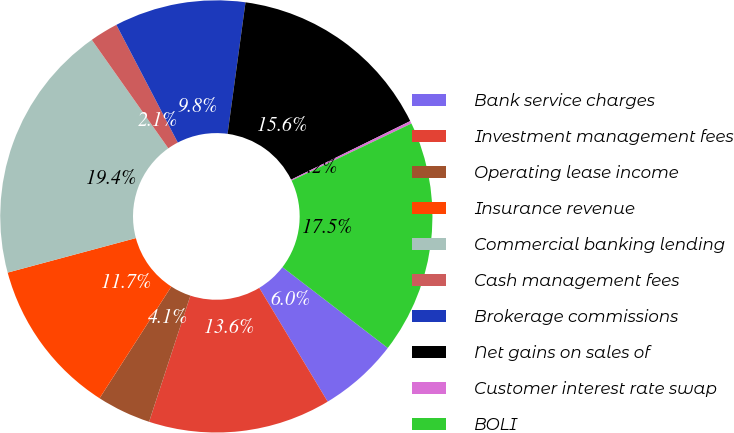Convert chart to OTSL. <chart><loc_0><loc_0><loc_500><loc_500><pie_chart><fcel>Bank service charges<fcel>Investment management fees<fcel>Operating lease income<fcel>Insurance revenue<fcel>Commercial banking lending<fcel>Cash management fees<fcel>Brokerage commissions<fcel>Net gains on sales of<fcel>Customer interest rate swap<fcel>BOLI<nl><fcel>5.97%<fcel>13.65%<fcel>4.05%<fcel>11.73%<fcel>19.41%<fcel>2.12%<fcel>9.81%<fcel>15.57%<fcel>0.2%<fcel>17.49%<nl></chart> 